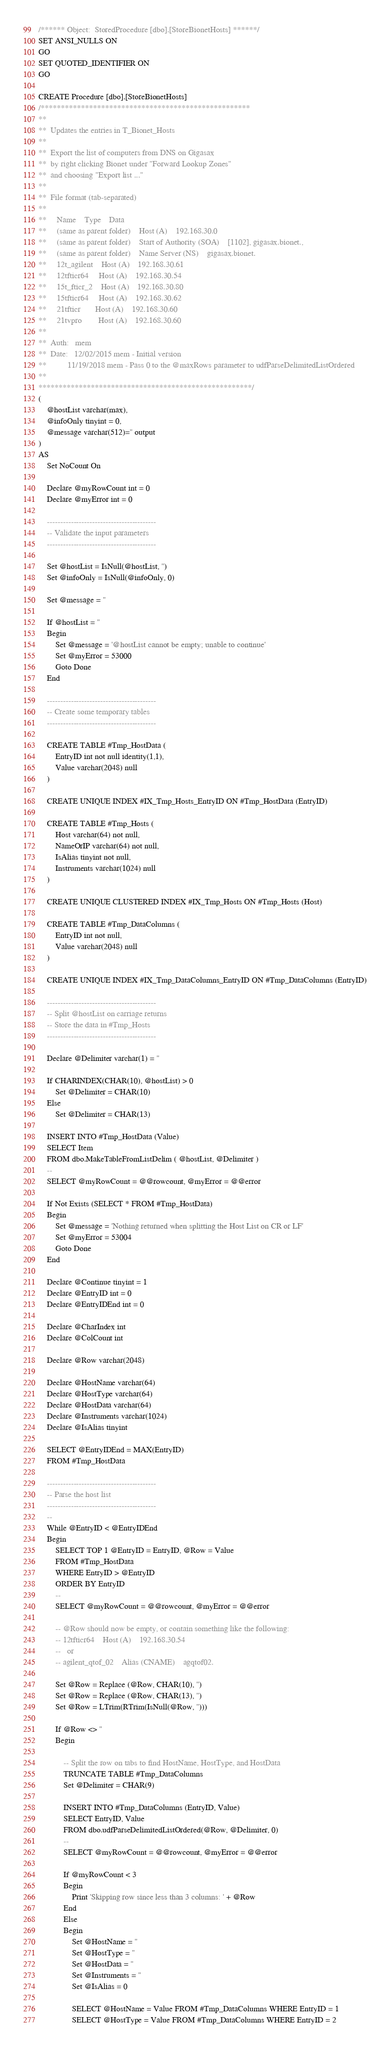Convert code to text. <code><loc_0><loc_0><loc_500><loc_500><_SQL_>/****** Object:  StoredProcedure [dbo].[StoreBionetHosts] ******/
SET ANSI_NULLS ON
GO
SET QUOTED_IDENTIFIER ON
GO

CREATE Procedure [dbo].[StoreBionetHosts]
/****************************************************
**
**  Updates the entries in T_Bionet_Hosts
**
**  Export the list of computers from DNS on Gigasax
**  by right clicking Bionet under "Forward Lookup Zones"
**  and choosing "Export list ..."
**        
**  File format (tab-separated)
**
**     Name    Type    Data
**     (same as parent folder)    Host (A)    192.168.30.0
**     (same as parent folder)    Start of Authority (SOA)    [1102], gigasax.bionet., 
**     (same as parent folder)    Name Server (NS)    gigasax.bionet.
**     12t_agilent    Host (A)    192.168.30.61
**     12tfticr64     Host (A)    192.168.30.54
**     15t_fticr_2    Host (A)    192.168.30.80
**     15tfticr64     Host (A)    192.168.30.62
**     21tfticr       Host (A)    192.168.30.60
**     21tvpro        Host (A)    192.168.30.60
**
**  Auth:   mem
**  Date:   12/02/2015 mem - Initial version
**          11/19/2018 mem - Pass 0 to the @maxRows parameter to udfParseDelimitedListOrdered
**    
*****************************************************/
(
    @hostList varchar(max),
    @infoOnly tinyint = 0,
    @message varchar(512)='' output
)
AS
    Set NoCount On

    Declare @myRowCount int = 0
    Declare @myError int = 0
    
    -----------------------------------------
    -- Validate the input parameters
    -----------------------------------------
    
    Set @hostList = IsNull(@hostList, '')
    Set @infoOnly = IsNull(@infoOnly, 0)
    
    Set @message = ''
    
    If @hostList = ''
    Begin
        Set @message = '@hostList cannot be empty; unable to continue'
        Set @myError = 53000
        Goto Done
    End

    -----------------------------------------
    -- Create some temporary tables
    -----------------------------------------
    
    CREATE TABLE #Tmp_HostData (
        EntryID int not null identity(1,1),
        Value varchar(2048) null
    )
    
    CREATE UNIQUE INDEX #IX_Tmp_Hosts_EntryID ON #Tmp_HostData (EntryID)

    CREATE TABLE #Tmp_Hosts (
        Host varchar(64) not null,
        NameOrIP varchar(64) not null,
        IsAlias tinyint not null,
        Instruments varchar(1024) null
    )
    
    CREATE UNIQUE CLUSTERED INDEX #IX_Tmp_Hosts ON #Tmp_Hosts (Host)

    CREATE TABLE #Tmp_DataColumns (
        EntryID int not null,
        Value varchar(2048) null
    )
    
    CREATE UNIQUE INDEX #IX_Tmp_DataColumns_EntryID ON #Tmp_DataColumns (EntryID)
    
    -----------------------------------------
    -- Split @hostList on carriage returns
    -- Store the data in #Tmp_Hosts
    -----------------------------------------

    Declare @Delimiter varchar(1) = ''

    If CHARINDEX(CHAR(10), @hostList) > 0
        Set @Delimiter = CHAR(10)
    Else
        Set @Delimiter = CHAR(13)
    
    INSERT INTO #Tmp_HostData (Value)
    SELECT Item
    FROM dbo.MakeTableFromListDelim ( @hostList, @Delimiter )
    --
    SELECT @myRowCount = @@rowcount, @myError = @@error
    
    If Not Exists (SELECT * FROM #Tmp_HostData)
    Begin
        Set @message = 'Nothing returned when splitting the Host List on CR or LF'
        Set @myError = 53004
        Goto Done
    End
    
    Declare @Continue tinyint = 1
    Declare @EntryID int = 0
    Declare @EntryIDEnd int = 0
    
    Declare @CharIndex int
    Declare @ColCount int

    Declare @Row varchar(2048)
    
    Declare @HostName varchar(64)
    Declare @HostType varchar(64)
    Declare @HostData varchar(64)
    Declare @Instruments varchar(1024)
    Declare @IsAlias tinyint
    
    SELECT @EntryIDEnd = MAX(EntryID)
    FROM #Tmp_HostData
    
    -----------------------------------------
    -- Parse the host list
    -----------------------------------------
    --
    While @EntryID < @EntryIDEnd
    Begin
        SELECT TOP 1 @EntryID = EntryID, @Row = Value
        FROM #Tmp_HostData
        WHERE EntryID > @EntryID
        ORDER BY EntryID
        --
        SELECT @myRowCount = @@rowcount, @myError = @@error
        
        -- @Row should now be empty, or contain something like the following:
        -- 12tfticr64    Host (A)    192.168.30.54
        --   or
        -- agilent_qtof_02    Alias (CNAME)    agqtof02.
        
        Set @Row = Replace (@Row, CHAR(10), '')
        Set @Row = Replace (@Row, CHAR(13), '')
        Set @Row = LTrim(RTrim(IsNull(@Row, '')))
        
        If @Row <> ''
        Begin

            -- Split the row on tabs to find HostName, HostType, and HostData
            TRUNCATE TABLE #Tmp_DataColumns
            Set @Delimiter = CHAR(9)
            
            INSERT INTO #Tmp_DataColumns (EntryID, Value)
            SELECT EntryID, Value
            FROM dbo.udfParseDelimitedListOrdered(@Row, @Delimiter, 0)
            --
            SELECT @myRowCount = @@rowcount, @myError = @@error

            If @myRowCount < 3
            Begin
                Print 'Skipping row since less than 3 columns: ' + @Row
            End
            Else
            Begin
                Set @HostName = ''
                Set @HostType = ''
                Set @HostData = ''
                Set @Instruments = ''
                Set @IsAlias = 0
                
                SELECT @HostName = Value FROM #Tmp_DataColumns WHERE EntryID = 1
                SELECT @HostType = Value FROM #Tmp_DataColumns WHERE EntryID = 2</code> 